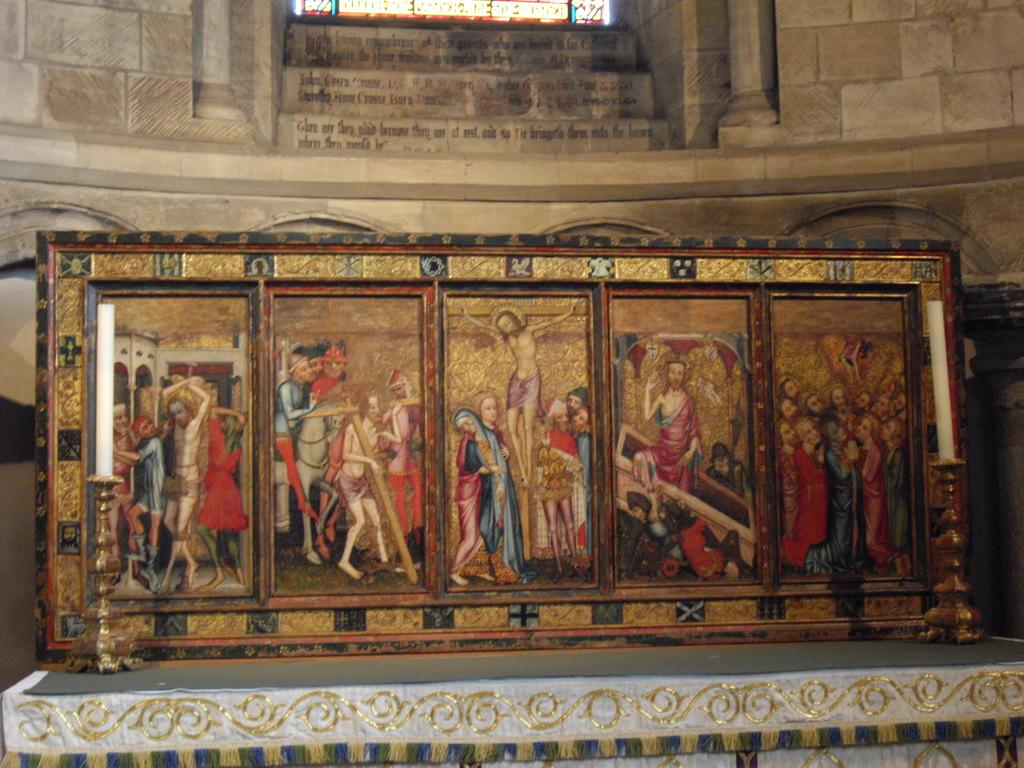What object is present in the center of the image? There is a photo frame in the image, and it is in the middle of the image. What is the photo frame placed on? The photo frame is placed on an object, but the specific object is not mentioned in the facts. What can be seen in the background of the image? There is a wall in the background of the image. What type of wine is being served on the tray in the image? There is no wine or tray present in the image; it only features a photo frame and a wall in the background. 